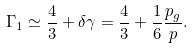<formula> <loc_0><loc_0><loc_500><loc_500>\Gamma _ { 1 } \simeq \frac { 4 } { 3 } + \delta \gamma = \frac { 4 } { 3 } + \frac { 1 } { 6 } \frac { p _ { g } } { p } .</formula> 